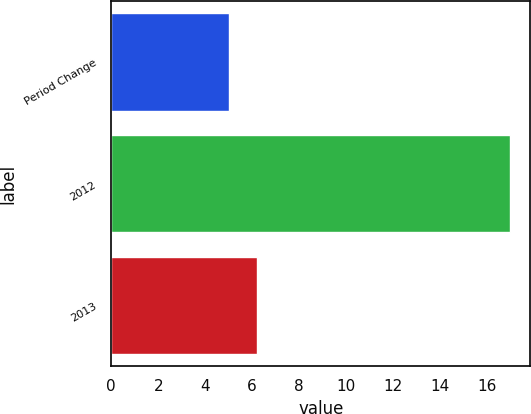Convert chart. <chart><loc_0><loc_0><loc_500><loc_500><bar_chart><fcel>Period Change<fcel>2012<fcel>2013<nl><fcel>5<fcel>17<fcel>6.2<nl></chart> 